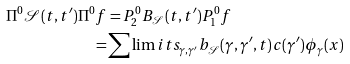<formula> <loc_0><loc_0><loc_500><loc_500>\Pi ^ { 0 } \mathcal { S } ( t , t ^ { \prime } ) \Pi ^ { 0 } f & = P ^ { 0 } _ { 2 } B _ { \mathcal { S } } ( t , t ^ { \prime } ) P _ { 1 } ^ { 0 } f \\ = & \sum \lim i t s _ { \gamma , \gamma ^ { \prime } } b _ { \mathcal { S } } ( \gamma , \gamma ^ { \prime } , t ) c ( \gamma ^ { \prime } ) \phi _ { \gamma } ( x )</formula> 